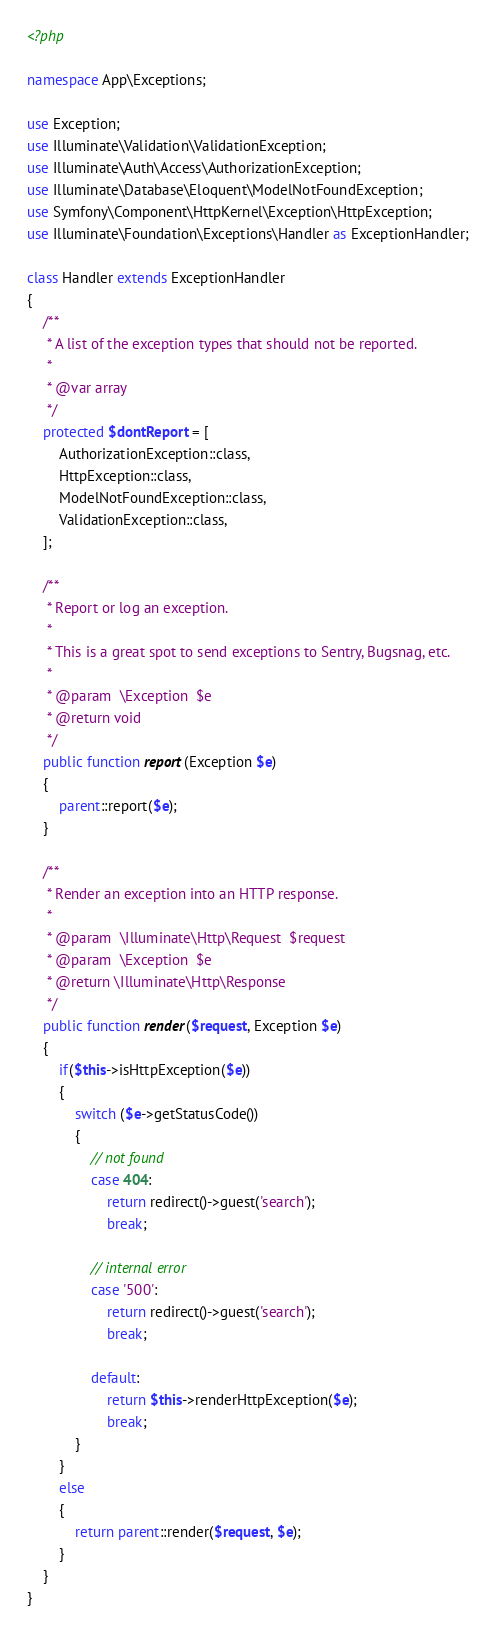<code> <loc_0><loc_0><loc_500><loc_500><_PHP_><?php

namespace App\Exceptions;

use Exception;
use Illuminate\Validation\ValidationException;
use Illuminate\Auth\Access\AuthorizationException;
use Illuminate\Database\Eloquent\ModelNotFoundException;
use Symfony\Component\HttpKernel\Exception\HttpException;
use Illuminate\Foundation\Exceptions\Handler as ExceptionHandler;

class Handler extends ExceptionHandler
{
    /**
     * A list of the exception types that should not be reported.
     *
     * @var array
     */
    protected $dontReport = [
        AuthorizationException::class,
        HttpException::class,
        ModelNotFoundException::class,
        ValidationException::class,
    ];

    /**
     * Report or log an exception.
     *
     * This is a great spot to send exceptions to Sentry, Bugsnag, etc.
     *
     * @param  \Exception  $e
     * @return void
     */
    public function report(Exception $e)
    {
        parent::report($e);
    }

    /**
     * Render an exception into an HTTP response.
     *
     * @param  \Illuminate\Http\Request  $request
     * @param  \Exception  $e
     * @return \Illuminate\Http\Response
     */
    public function render($request, Exception $e)
    {
        if($this->isHttpException($e))
        {
            switch ($e->getStatusCode())
            {
                // not found
                case 404:
                    return redirect()->guest('search');
                    break;

                // internal error
                case '500':
                    return redirect()->guest('search');
                    break;

                default:
                    return $this->renderHttpException($e);
                    break;
            }
        }
        else
        {
            return parent::render($request, $e);
        }
    }
}</code> 